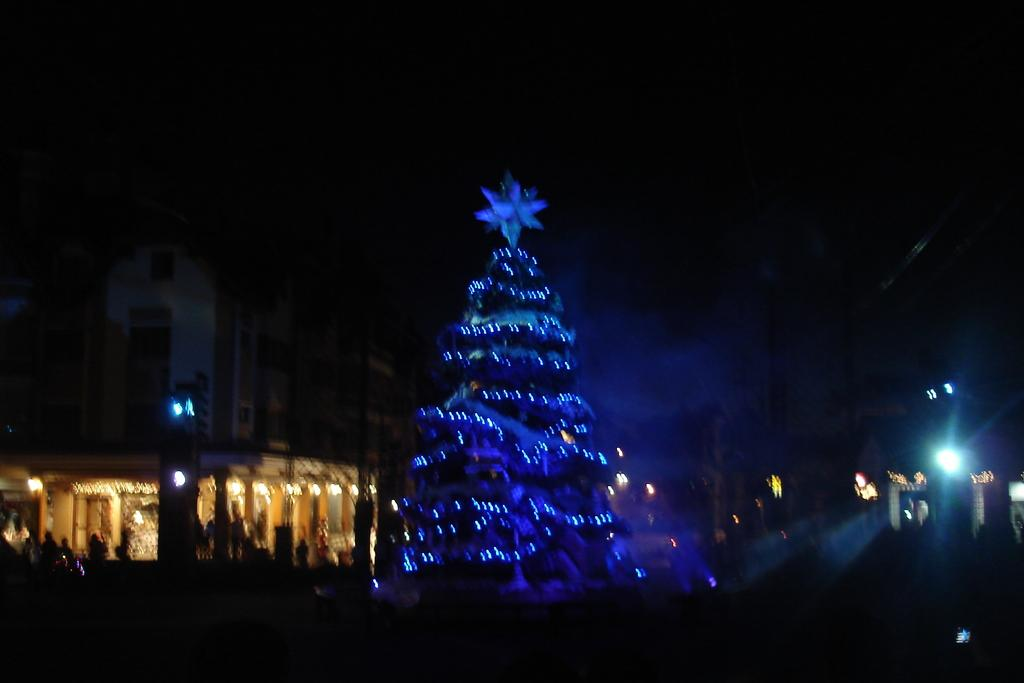What is the lighting condition in the image? The image was taken in the dark. What is the main subject in the image? There is a Xmas tree in the middle of the image. What can be seen in the background of the image? There are buildings and lights visible in the background of the image. What type of quill is being used to write on the jar in the image? There is no quill or jar present in the image. How many horses can be seen in the image? There are no horses visible in the image. 